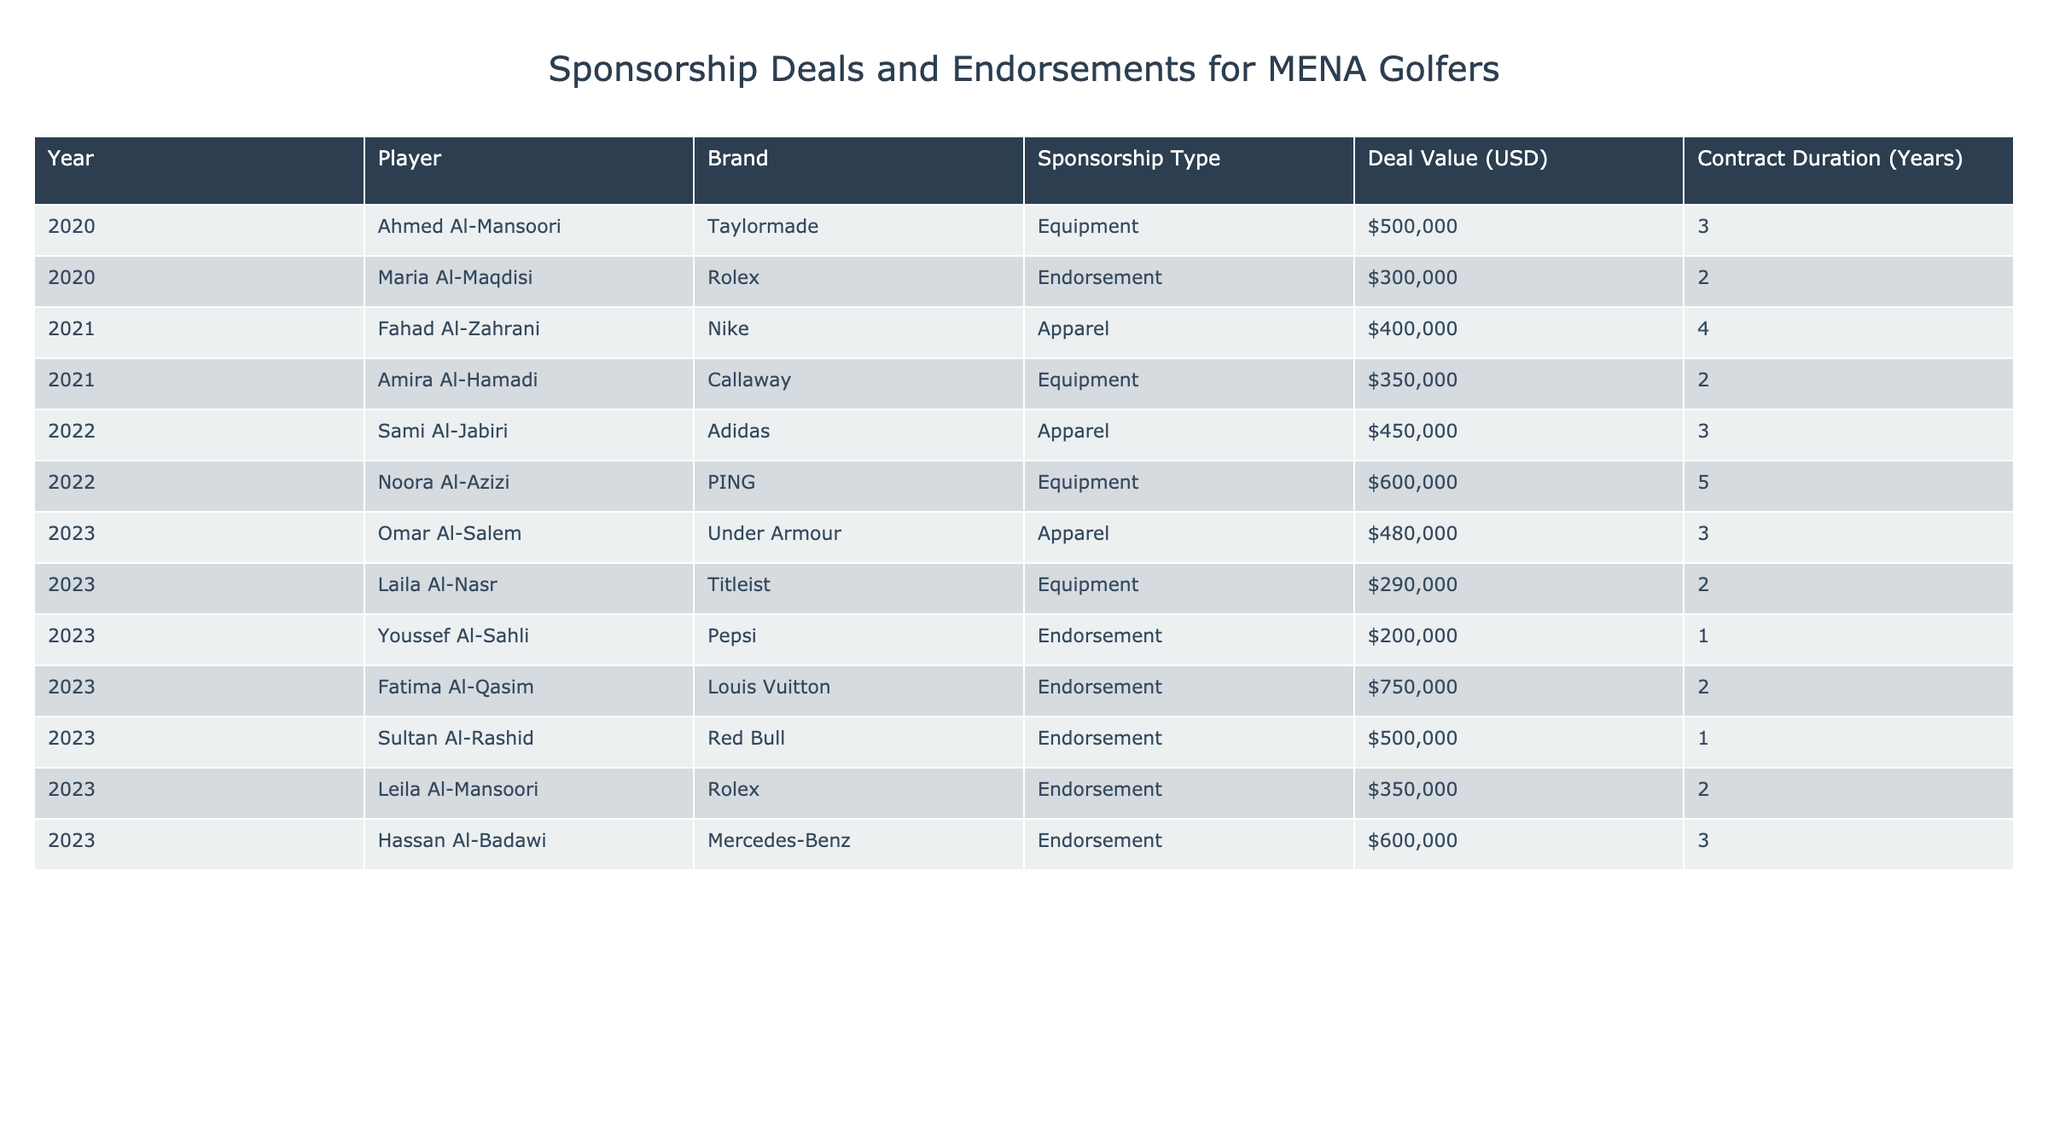What is the sponsorship deal value for Ahmed Al-Mansoori? In the table, there is a row for Ahmed Al-Mansoori under the year 2020. The deal value listed for his deal with Taylormade is $500,000.
Answer: $500,000 Which brand has the highest endorsement value for 2023? In the table, the endorsements for 2023 show Fatima Al-Qasim with Louis Vuitton having a deal value of $750,000, which is higher than the other endorsement deals listed for that year.
Answer: Louis Vuitton How many years is Sami Al-Jabiri's deal with Adidas? Sami Al-Jabiri's deal is listed under the year 2022, and the contract duration for this deal is stated as 3 years.
Answer: 3 years What is the total deal value for all sponsorships in 2021? To find the total for 2021, we sum the deal values for Fahad Al-Zahrani ($400,000) and Amira Al-Hamadi ($350,000), which gives us $400,000 + $350,000 = $750,000.
Answer: $750,000 Did Yamaha sign any sponsorship deals with golfers in the MENA region according to the table? The table lists various brands associated with golfers, and Yamaha is not mentioned in any row. Therefore, the answer is no.
Answer: No What is the average deal value for all endorsements listed in 2023? In 2023, the endorsement deal values are $200,000 (Youssef Al-Sahli), $750,000 (Fatima Al-Qasim), $500,000 (Sultan Al-Rashid), and $350,000 (Leila Al-Mansoori). Summing these up gives $200,000 + $750,000 + $500,000 + $350,000 = $1,800,000. Dividing by the number of endorsement deals (4) gives us an average of $1,800,000 / 4 = $450,000.
Answer: $450,000 Which player has the longest contract duration and what is it? By examining the table, we see that Noora Al-Azizi has a deal with PING for 5 years, which is the longest duration compared to other contracts listed.
Answer: 5 years How many players signed endorsements in 2023? In 2023, four players signed endorsement deals: Youssef Al-Sahli, Fatima Al-Qasim, Sultan Al-Rashid, and Leila Al-Mansoori. Therefore, there are four players.
Answer: 4 players What is the total deal value for all apparel sponsorships listed? The apparel sponsorships are from 2021 (Nike), 2022 (Adidas), and 2023 (Under Armour). The deal values are $400,000 (Nike), $450,000 (Adidas), and $480,000 (Under Armour). Summing these gives $400,000 + $450,000 + $480,000 = $1,330,000.
Answer: $1,330,000 